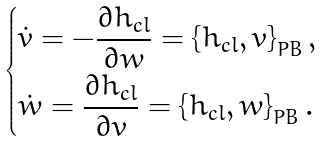<formula> <loc_0><loc_0><loc_500><loc_500>\begin{dcases} \dot { v } = - \frac { \partial h _ { c l } } { \partial w } = \left \{ h _ { c l } , v \right \} _ { P B } , \\ \dot { w } = \frac { \partial h _ { c l } } { \partial v } = \left \{ h _ { c l } , w \right \} _ { P B } . \end{dcases}</formula> 